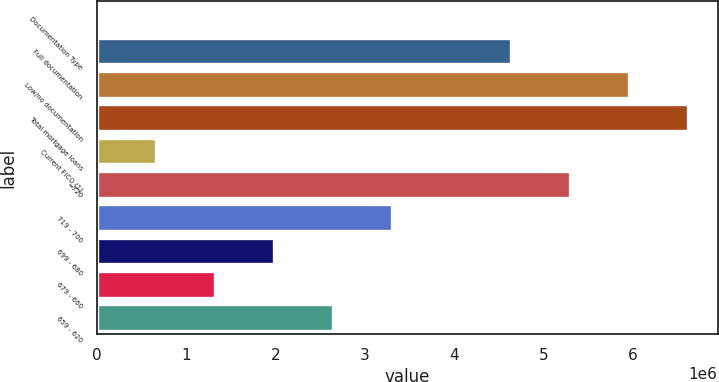Convert chart. <chart><loc_0><loc_0><loc_500><loc_500><bar_chart><fcel>Documentation Type<fcel>Full documentation<fcel>Low/no documentation<fcel>Total mortgage loans<fcel>Current FICO (1)<fcel>=720<fcel>719 - 700<fcel>699 - 680<fcel>679 - 660<fcel>659 - 620<nl><fcel>2011<fcel>4.63167e+06<fcel>5.95443e+06<fcel>6.61581e+06<fcel>663391<fcel>5.29305e+06<fcel>3.30891e+06<fcel>1.98615e+06<fcel>1.32477e+06<fcel>2.64753e+06<nl></chart> 